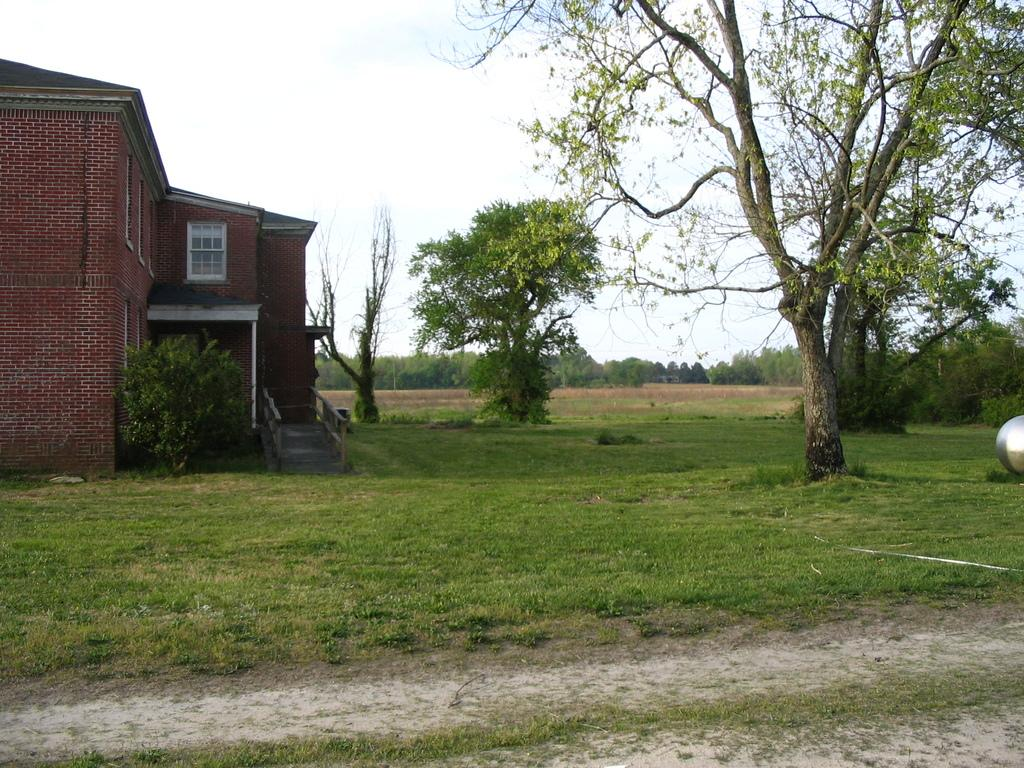What type of vegetation covers the land in the image? The land is covered with grass. What type of structure is present in the image? There is a building with windows in the image. What is located in front of the building? There is a plant and trees in front of the building. Are there any trees visible in the distance? Yes, there are a number of trees far away from the building. How much waste is visible in the image? There is no visible waste in the image. How many steps are required to reach the building from the trees? The image does not provide information about the distance or number of steps required to reach the building from the trees. 